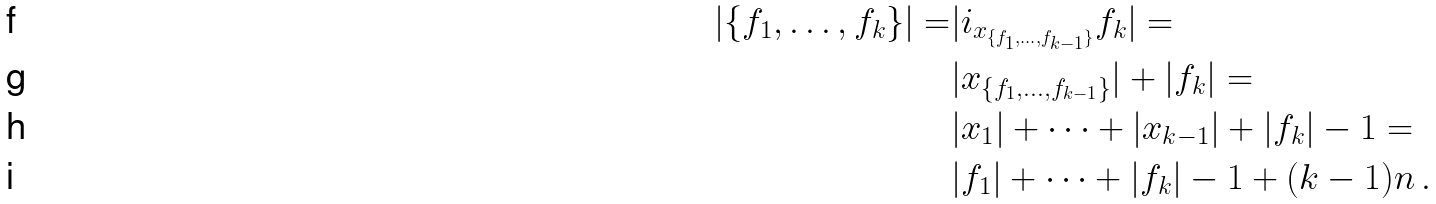<formula> <loc_0><loc_0><loc_500><loc_500>| \{ f _ { 1 } , \dots , f _ { k } \} | = & | i _ { x _ { \{ f _ { 1 } , \dots , f _ { k - 1 } \} } } f _ { k } | = \\ & | x _ { \{ f _ { 1 } , \dots , f _ { k - 1 } \} } | + | f _ { k } | = \\ & | x _ { 1 } | + \cdots + | x _ { k - 1 } | + | f _ { k } | - 1 = \\ & | f _ { 1 } | + \cdots + | f _ { k } | - 1 + ( k - 1 ) n \, .</formula> 